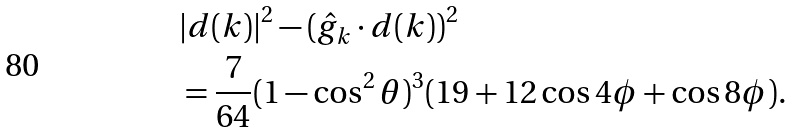<formula> <loc_0><loc_0><loc_500><loc_500>& | d ( k ) | ^ { 2 } - ( \hat { g } _ { k } \cdot d ( k ) ) ^ { 2 } \\ & = \frac { 7 } { 6 4 } ( 1 - \cos ^ { 2 } \theta ) ^ { 3 } ( 1 9 + 1 2 \cos 4 \phi + \cos 8 \phi ) .</formula> 